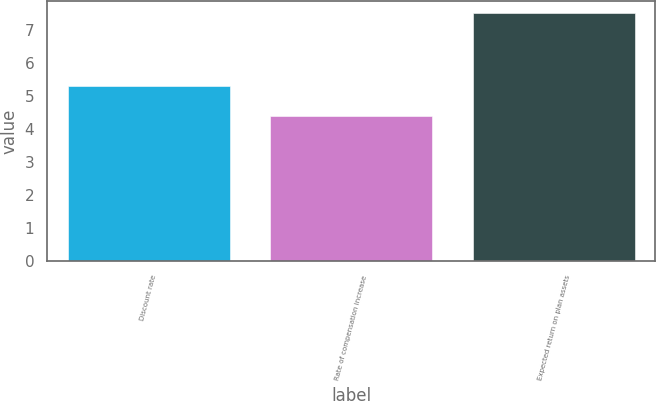Convert chart. <chart><loc_0><loc_0><loc_500><loc_500><bar_chart><fcel>Discount rate<fcel>Rate of compensation increase<fcel>Expected return on plan assets<nl><fcel>5.3<fcel>4.4<fcel>7.5<nl></chart> 